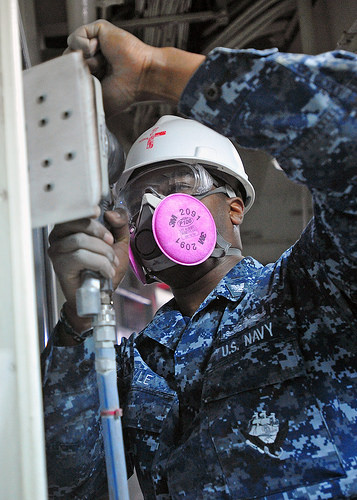<image>
Can you confirm if the cross is on the helmet? Yes. Looking at the image, I can see the cross is positioned on top of the helmet, with the helmet providing support. 